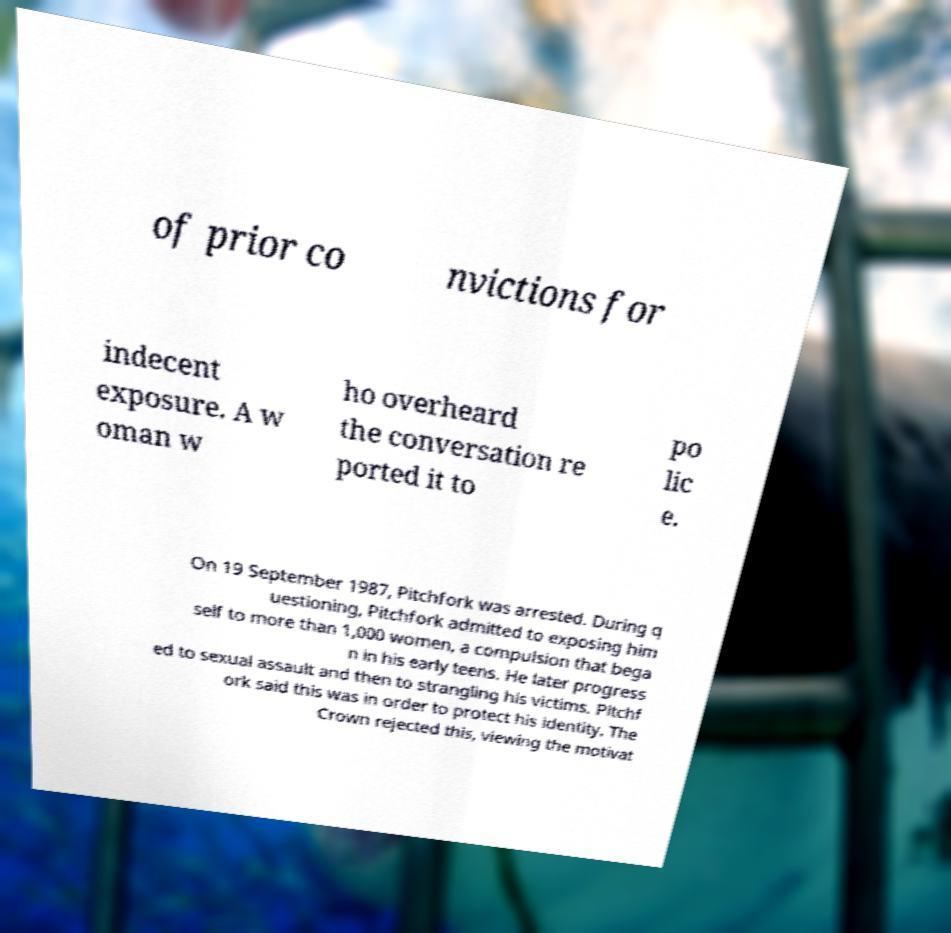Could you assist in decoding the text presented in this image and type it out clearly? of prior co nvictions for indecent exposure. A w oman w ho overheard the conversation re ported it to po lic e. On 19 September 1987, Pitchfork was arrested. During q uestioning, Pitchfork admitted to exposing him self to more than 1,000 women, a compulsion that bega n in his early teens. He later progress ed to sexual assault and then to strangling his victims. Pitchf ork said this was in order to protect his identity. The Crown rejected this, viewing the motivat 